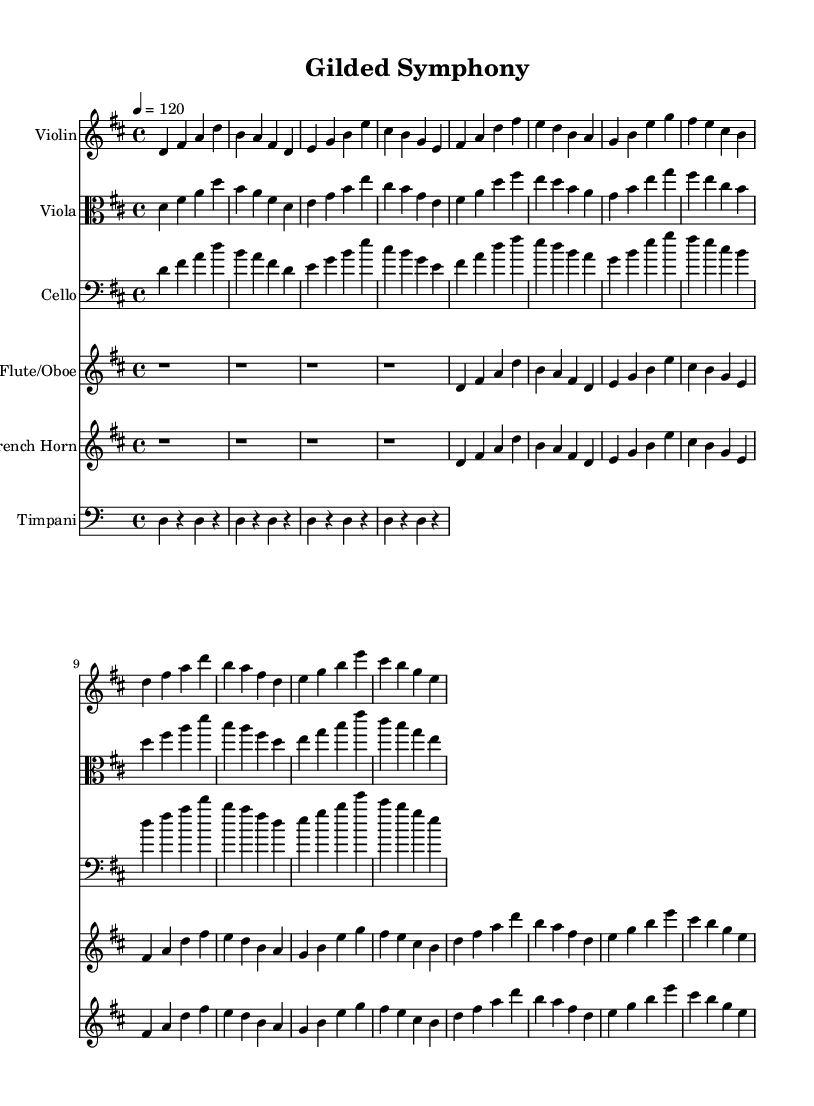What is the key signature of this music? The key signature is D major, which has two sharps (F# and C#).
Answer: D major What is the time signature of this composition? The time signature is 4/4, indicating four beats per measure.
Answer: 4/4 What is the tempo marking for this piece? The tempo marking is 120 beats per minute, indicating a moderate pace.
Answer: 120 How many measures are in the verse section? The verse section consists of two measures as per the given notes.
Answer: 2 Which instruments are included in this arrangement? The arrangement includes Violin, Viola, Cello, Flute/Oboe, French Horn, and Timpani.
Answer: Violin, Viola, Cello, Flute, Oboe, French Horn, Timpani What musical form does the chorus follow? The chorus follows a similar structure to the verse, maintaining the same melodic line.
Answer: Similar to the verse How do the orchestral elements enhance the pop style of this piece? The opulent orchestral arrangements provide grandeur, complementing modern pop beats with richness.
Answer: Opulent orchestral arrangements 